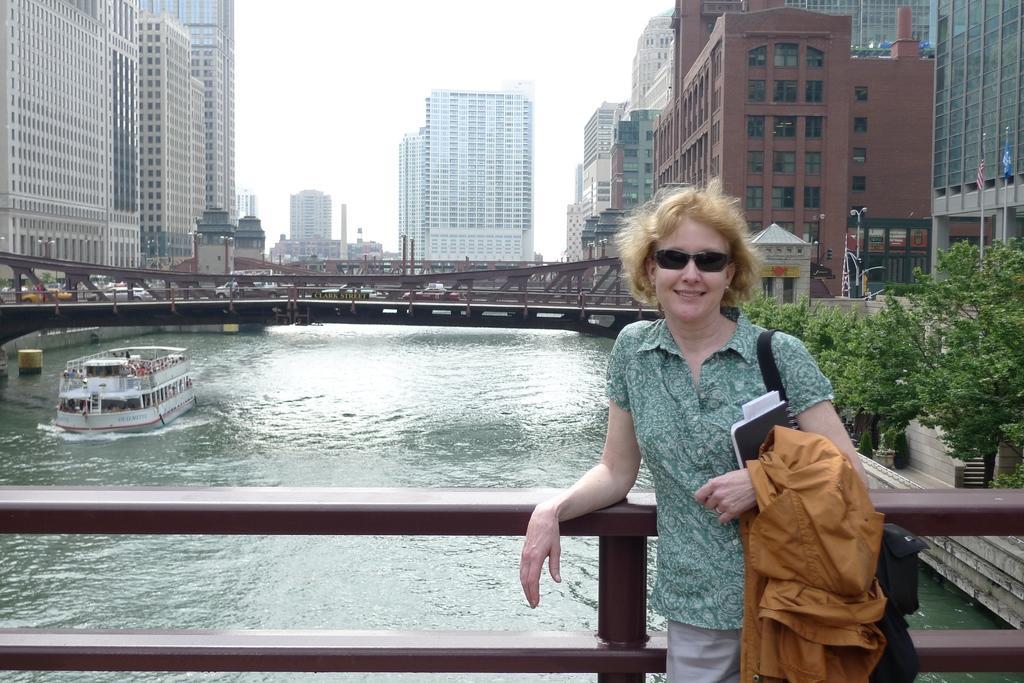Could you give a brief overview of what you see in this image? In this picture there is a woman who is wearing google, shirt and trouser. She is holding a bag, book, jacket and she is smiling. She is standing near to the railing. On the left I can see many peoples were sitting inside the boat which is on the water. In the center I can see the trucks, cars and other vehicles on the bridge. In the background I can see the skyscrapers, buildings and towers. At the top there is a sky. On the right I can see the flags in-front of the building. Beside that I can see the trees. 